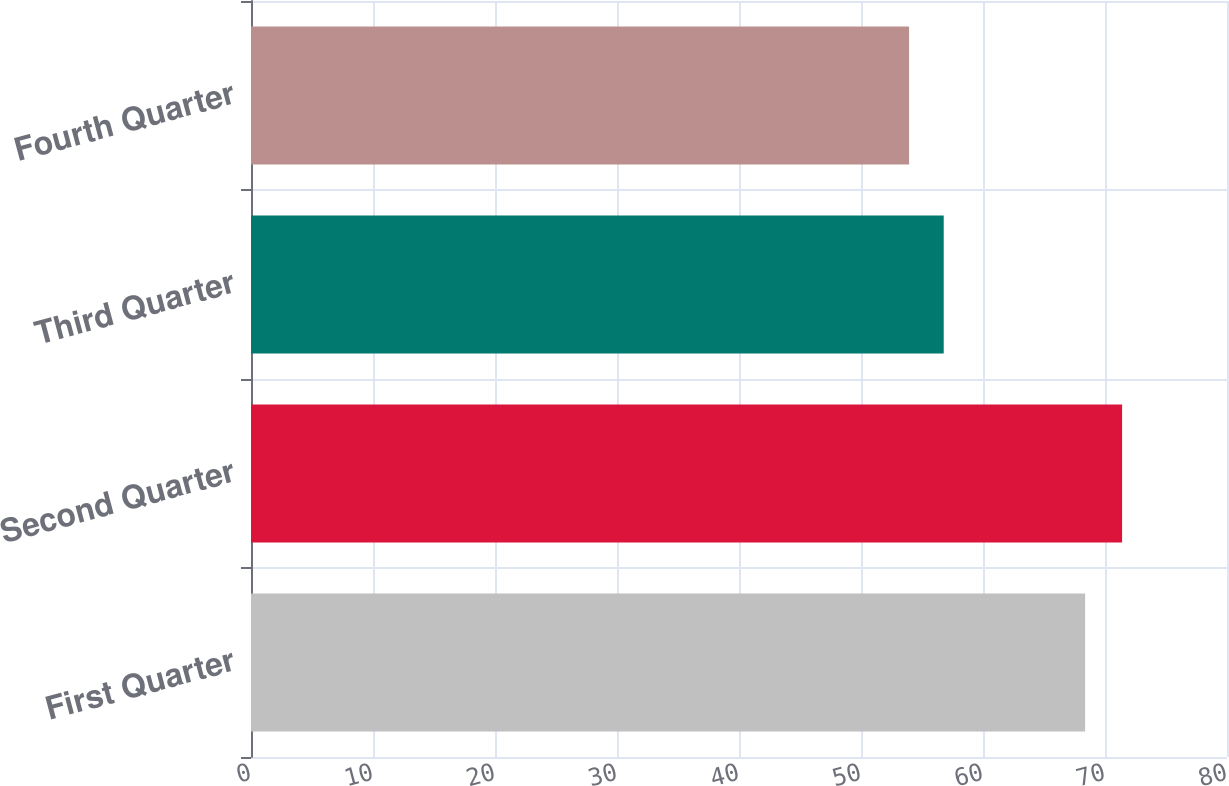<chart> <loc_0><loc_0><loc_500><loc_500><bar_chart><fcel>First Quarter<fcel>Second Quarter<fcel>Third Quarter<fcel>Fourth Quarter<nl><fcel>68.37<fcel>71.4<fcel>56.78<fcel>53.94<nl></chart> 